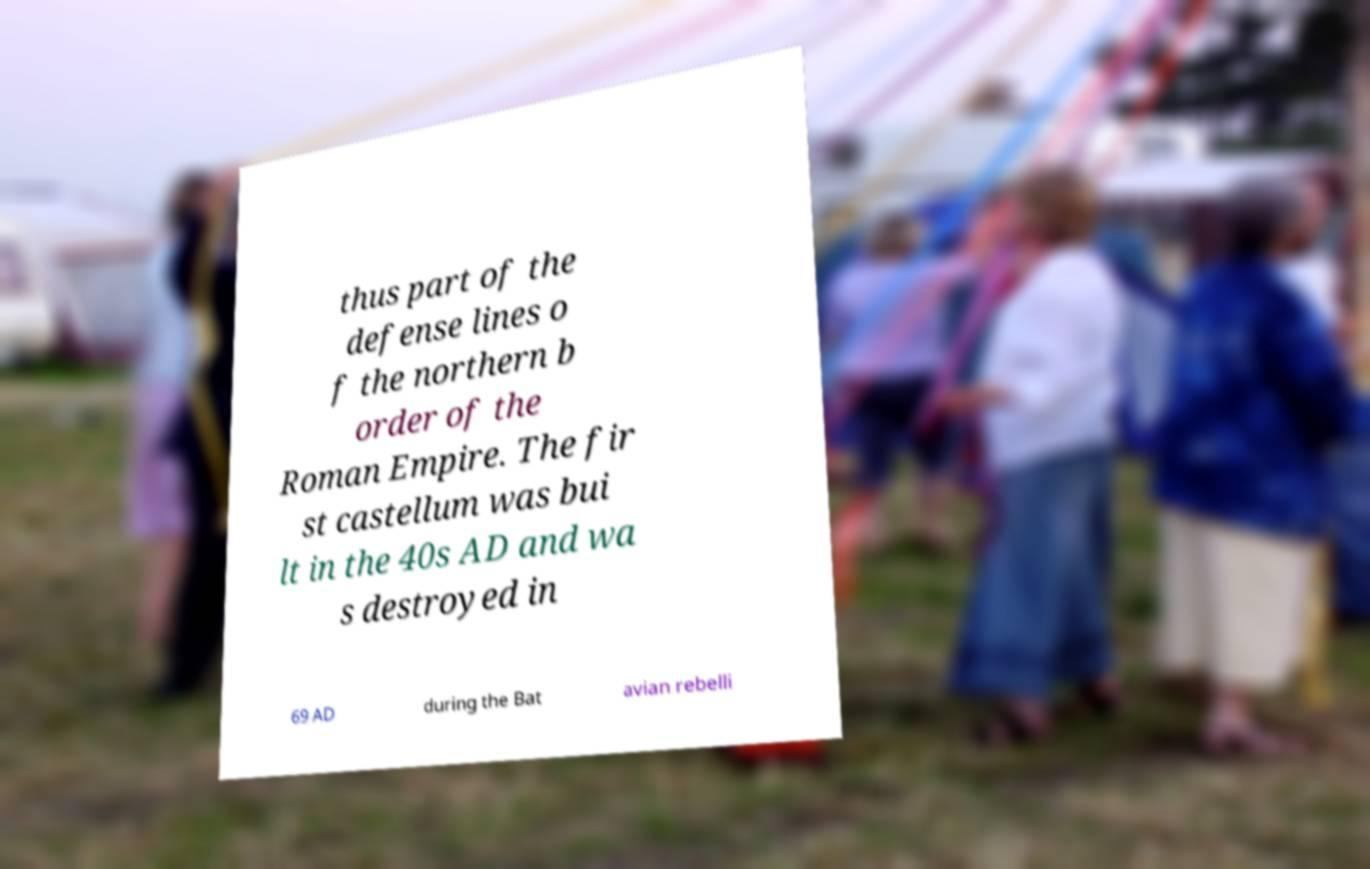What messages or text are displayed in this image? I need them in a readable, typed format. thus part of the defense lines o f the northern b order of the Roman Empire. The fir st castellum was bui lt in the 40s AD and wa s destroyed in 69 AD during the Bat avian rebelli 